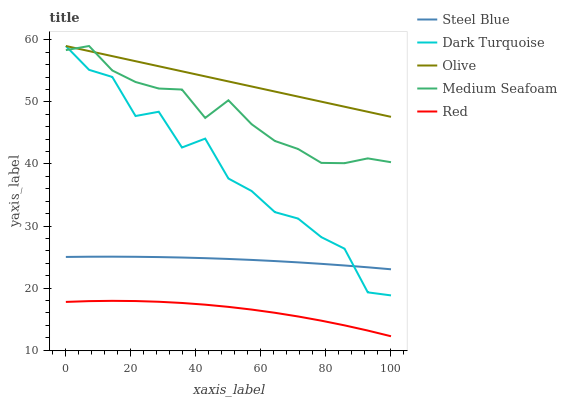Does Red have the minimum area under the curve?
Answer yes or no. Yes. Does Dark Turquoise have the minimum area under the curve?
Answer yes or no. No. Does Dark Turquoise have the maximum area under the curve?
Answer yes or no. No. Is Dark Turquoise the roughest?
Answer yes or no. Yes. Is Steel Blue the smoothest?
Answer yes or no. No. Is Steel Blue the roughest?
Answer yes or no. No. Does Dark Turquoise have the lowest value?
Answer yes or no. No. Does Steel Blue have the highest value?
Answer yes or no. No. Is Steel Blue less than Medium Seafoam?
Answer yes or no. Yes. Is Olive greater than Red?
Answer yes or no. Yes. Does Steel Blue intersect Medium Seafoam?
Answer yes or no. No. 